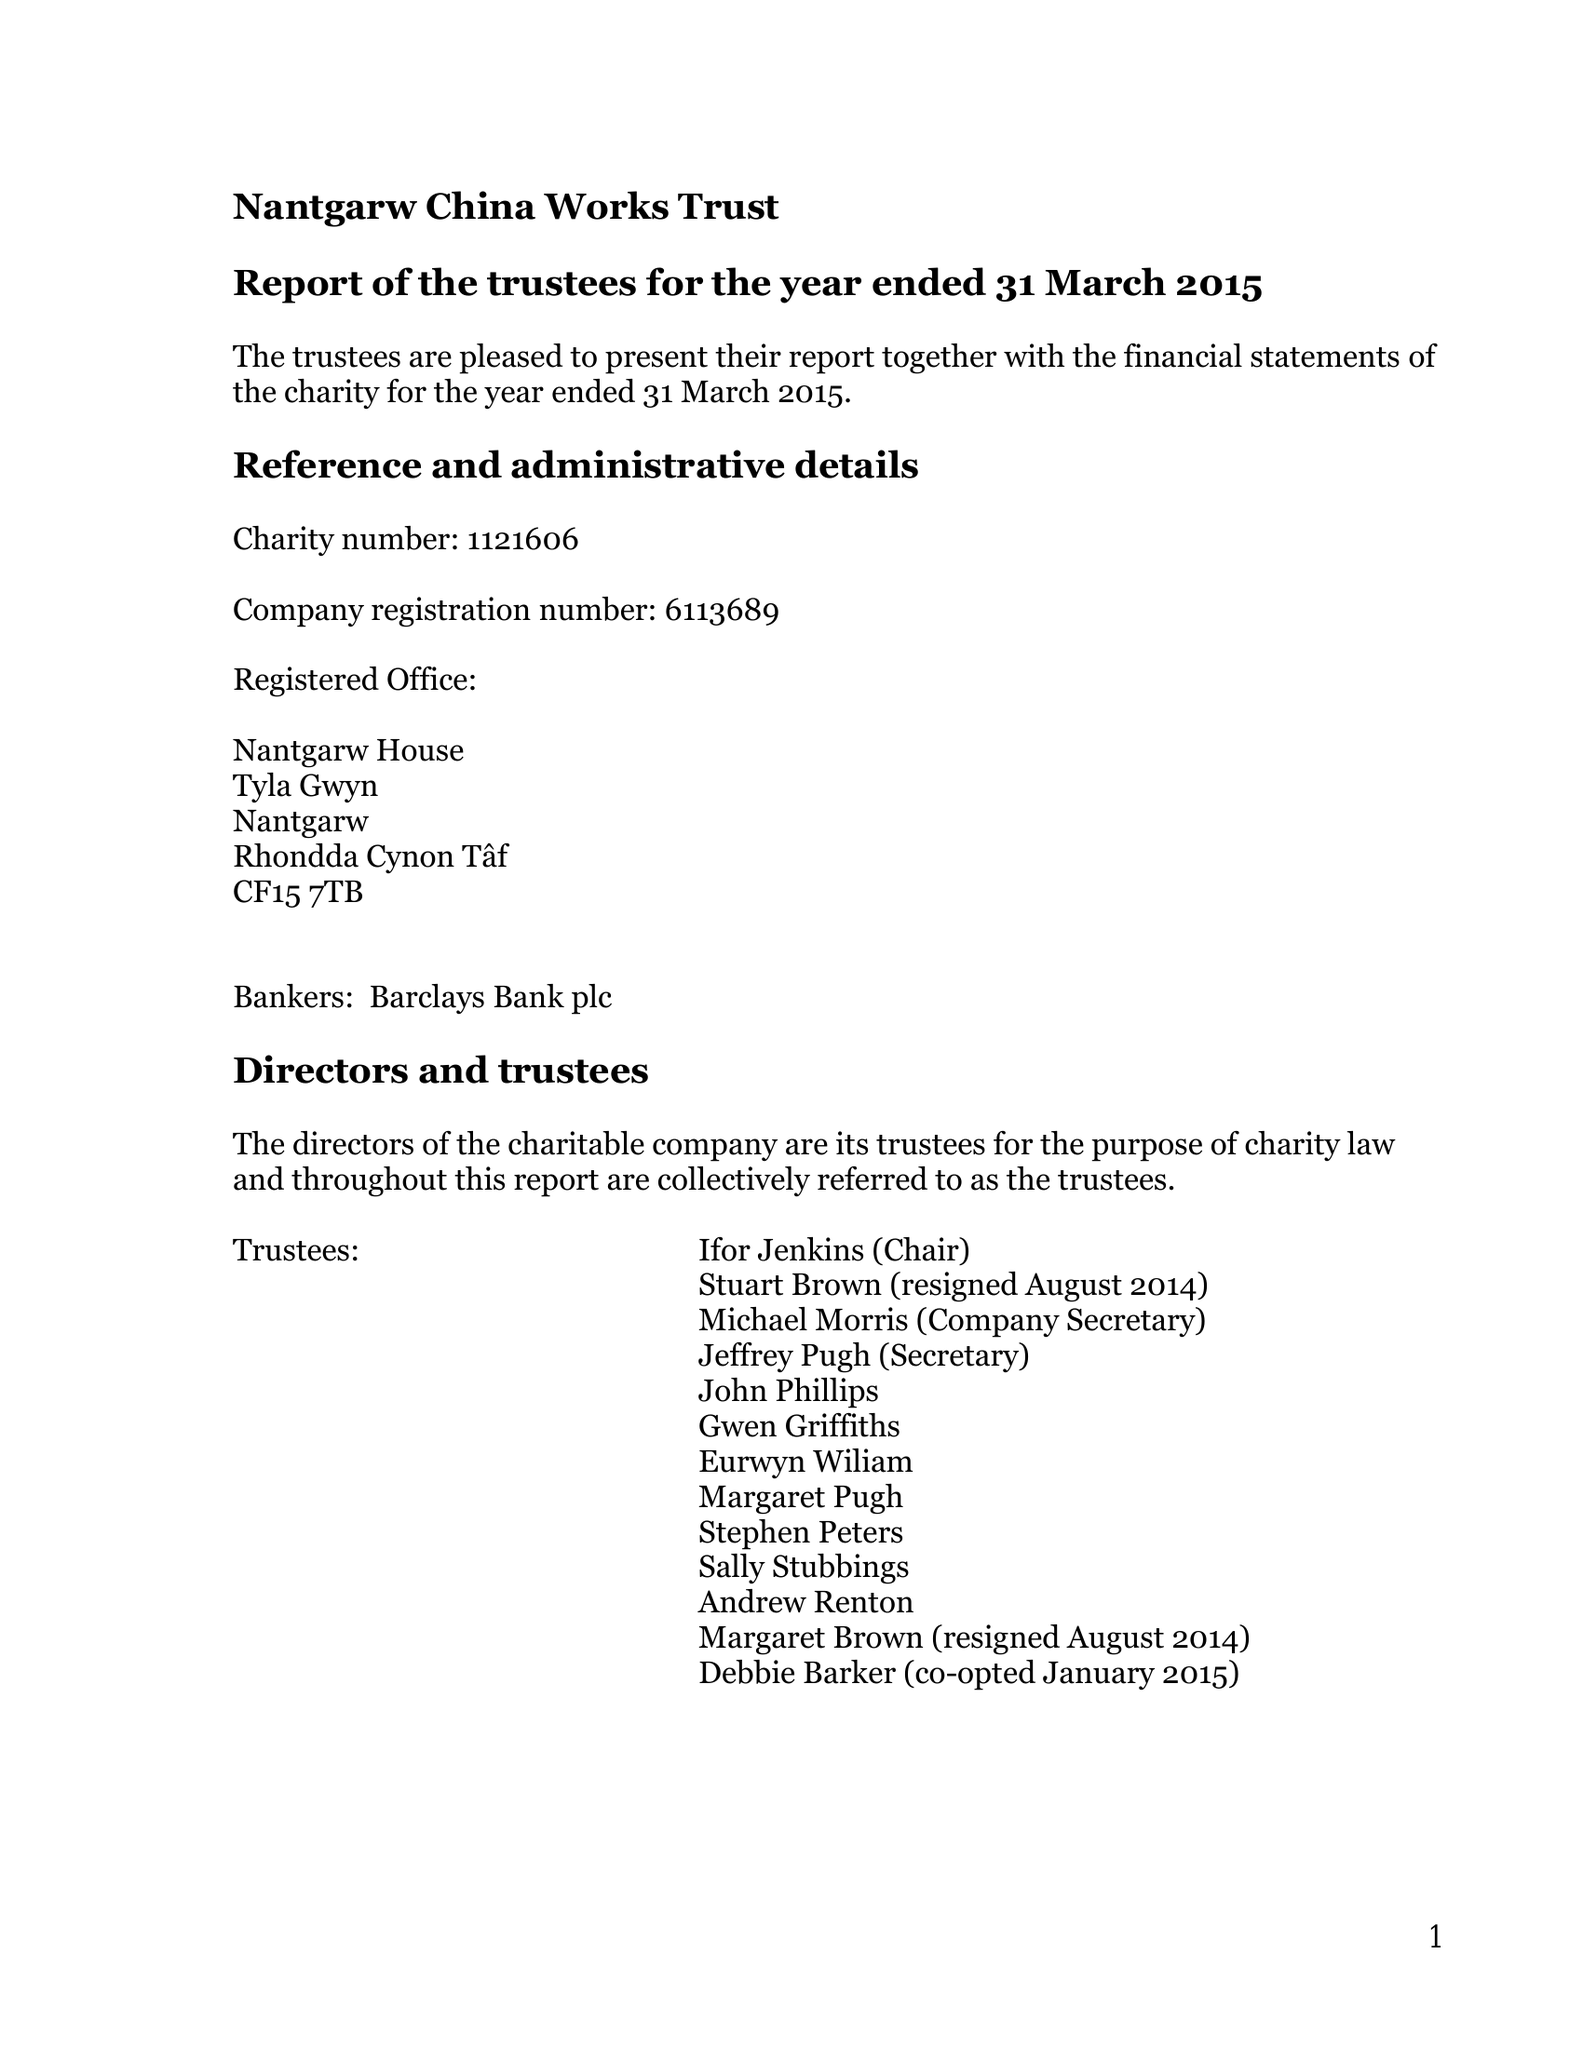What is the value for the charity_name?
Answer the question using a single word or phrase. Nantgarw China Works Trust 